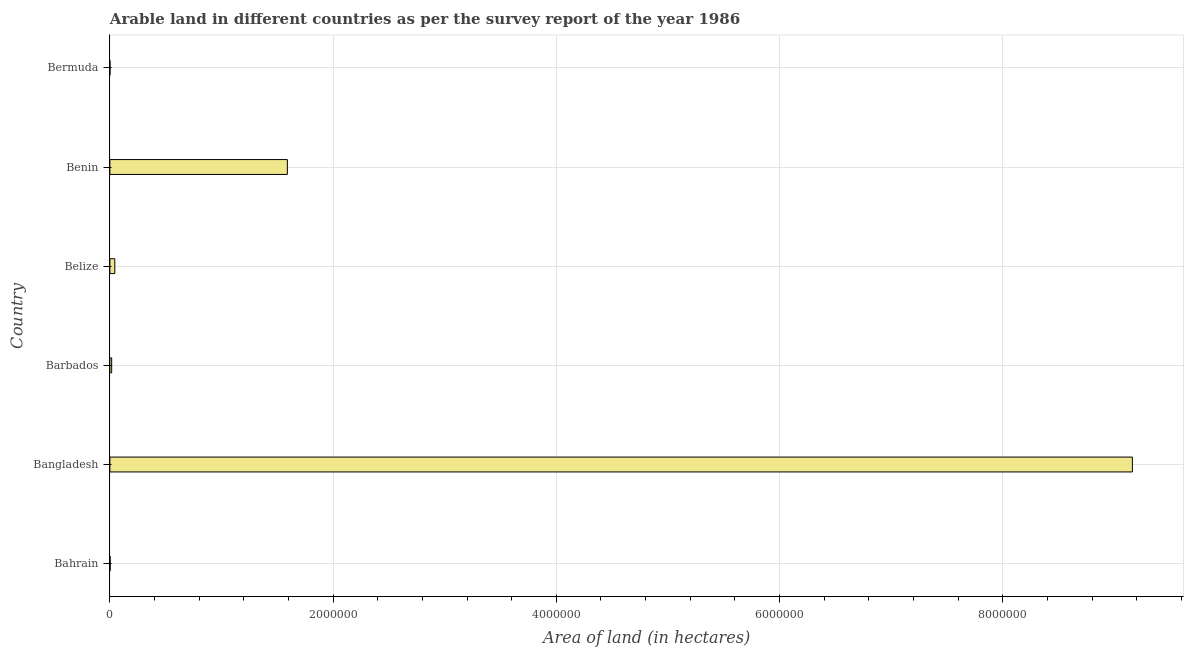Does the graph contain grids?
Offer a terse response. Yes. What is the title of the graph?
Your answer should be very brief. Arable land in different countries as per the survey report of the year 1986. What is the label or title of the X-axis?
Give a very brief answer. Area of land (in hectares). What is the area of land in Bangladesh?
Provide a short and direct response. 9.16e+06. Across all countries, what is the maximum area of land?
Keep it short and to the point. 9.16e+06. Across all countries, what is the minimum area of land?
Your response must be concise. 300. In which country was the area of land maximum?
Offer a terse response. Bangladesh. In which country was the area of land minimum?
Provide a short and direct response. Bermuda. What is the sum of the area of land?
Keep it short and to the point. 1.08e+07. What is the difference between the area of land in Belize and Bermuda?
Offer a very short reply. 4.37e+04. What is the average area of land per country?
Offer a terse response. 1.80e+06. What is the median area of land?
Provide a short and direct response. 3.00e+04. In how many countries, is the area of land greater than 6400000 hectares?
Keep it short and to the point. 1. What is the ratio of the area of land in Belize to that in Benin?
Offer a terse response. 0.03. What is the difference between the highest and the second highest area of land?
Offer a terse response. 7.57e+06. Is the sum of the area of land in Barbados and Bermuda greater than the maximum area of land across all countries?
Provide a succinct answer. No. What is the difference between the highest and the lowest area of land?
Provide a short and direct response. 9.16e+06. Are all the bars in the graph horizontal?
Provide a short and direct response. Yes. Are the values on the major ticks of X-axis written in scientific E-notation?
Give a very brief answer. No. What is the Area of land (in hectares) in Bangladesh?
Keep it short and to the point. 9.16e+06. What is the Area of land (in hectares) in Barbados?
Provide a succinct answer. 1.60e+04. What is the Area of land (in hectares) of Belize?
Your answer should be compact. 4.40e+04. What is the Area of land (in hectares) in Benin?
Keep it short and to the point. 1.59e+06. What is the Area of land (in hectares) of Bermuda?
Your response must be concise. 300. What is the difference between the Area of land (in hectares) in Bahrain and Bangladesh?
Provide a succinct answer. -9.16e+06. What is the difference between the Area of land (in hectares) in Bahrain and Barbados?
Keep it short and to the point. -1.40e+04. What is the difference between the Area of land (in hectares) in Bahrain and Belize?
Provide a short and direct response. -4.20e+04. What is the difference between the Area of land (in hectares) in Bahrain and Benin?
Ensure brevity in your answer.  -1.59e+06. What is the difference between the Area of land (in hectares) in Bahrain and Bermuda?
Give a very brief answer. 1700. What is the difference between the Area of land (in hectares) in Bangladesh and Barbados?
Provide a succinct answer. 9.14e+06. What is the difference between the Area of land (in hectares) in Bangladesh and Belize?
Give a very brief answer. 9.12e+06. What is the difference between the Area of land (in hectares) in Bangladesh and Benin?
Keep it short and to the point. 7.57e+06. What is the difference between the Area of land (in hectares) in Bangladesh and Bermuda?
Your answer should be very brief. 9.16e+06. What is the difference between the Area of land (in hectares) in Barbados and Belize?
Give a very brief answer. -2.80e+04. What is the difference between the Area of land (in hectares) in Barbados and Benin?
Ensure brevity in your answer.  -1.57e+06. What is the difference between the Area of land (in hectares) in Barbados and Bermuda?
Your answer should be very brief. 1.57e+04. What is the difference between the Area of land (in hectares) in Belize and Benin?
Give a very brief answer. -1.55e+06. What is the difference between the Area of land (in hectares) in Belize and Bermuda?
Make the answer very short. 4.37e+04. What is the difference between the Area of land (in hectares) in Benin and Bermuda?
Provide a short and direct response. 1.59e+06. What is the ratio of the Area of land (in hectares) in Bahrain to that in Bangladesh?
Your response must be concise. 0. What is the ratio of the Area of land (in hectares) in Bahrain to that in Belize?
Provide a succinct answer. 0.04. What is the ratio of the Area of land (in hectares) in Bahrain to that in Bermuda?
Provide a short and direct response. 6.67. What is the ratio of the Area of land (in hectares) in Bangladesh to that in Barbados?
Keep it short and to the point. 572.56. What is the ratio of the Area of land (in hectares) in Bangladesh to that in Belize?
Give a very brief answer. 208.21. What is the ratio of the Area of land (in hectares) in Bangladesh to that in Benin?
Your answer should be compact. 5.76. What is the ratio of the Area of land (in hectares) in Bangladesh to that in Bermuda?
Provide a short and direct response. 3.05e+04. What is the ratio of the Area of land (in hectares) in Barbados to that in Belize?
Ensure brevity in your answer.  0.36. What is the ratio of the Area of land (in hectares) in Barbados to that in Bermuda?
Provide a succinct answer. 53.33. What is the ratio of the Area of land (in hectares) in Belize to that in Benin?
Provide a succinct answer. 0.03. What is the ratio of the Area of land (in hectares) in Belize to that in Bermuda?
Make the answer very short. 146.67. What is the ratio of the Area of land (in hectares) in Benin to that in Bermuda?
Provide a succinct answer. 5300. 